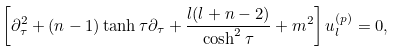<formula> <loc_0><loc_0><loc_500><loc_500>& \left [ \partial _ { \tau } ^ { 2 } + ( n - 1 ) \tanh \tau \partial _ { \tau } + \frac { l ( l + n - 2 ) } { \cosh ^ { 2 } \tau } + m ^ { 2 } \right ] u _ { l } ^ { ( p ) } = 0 ,</formula> 